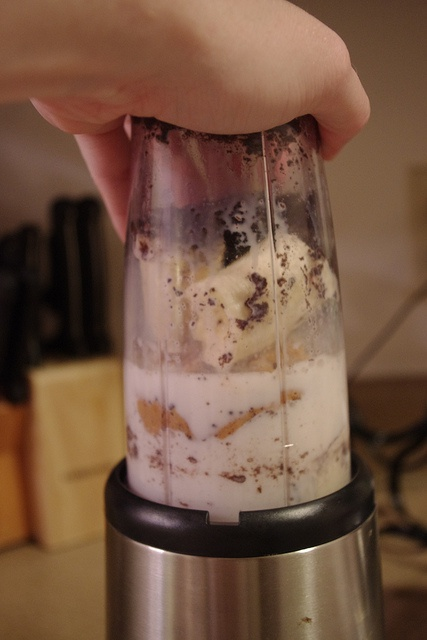Describe the objects in this image and their specific colors. I can see people in brown and tan tones, banana in brown, tan, and gray tones, banana in brown, darkgray, tan, and gray tones, and knife in black, maroon, and brown tones in this image. 